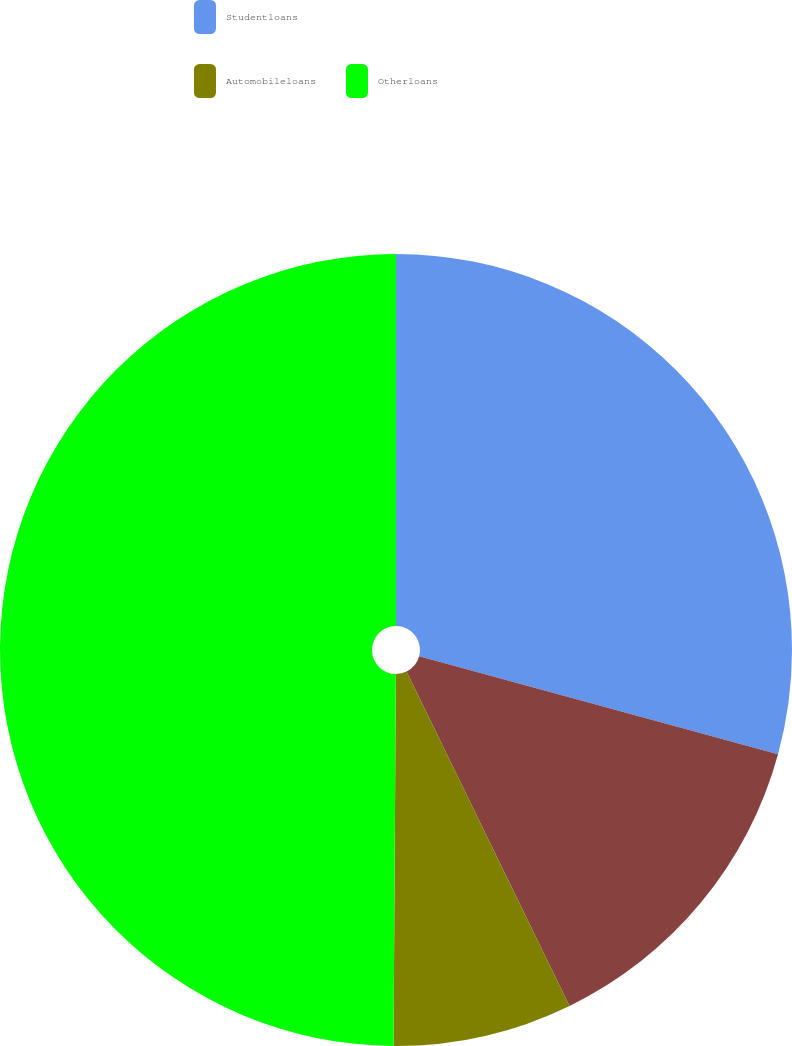Convert chart. <chart><loc_0><loc_0><loc_500><loc_500><pie_chart><fcel>Studentloans<fcel>Unnamed: 1<fcel>Automobileloans<fcel>Otherloans<nl><fcel>29.24%<fcel>13.54%<fcel>7.32%<fcel>49.9%<nl></chart> 